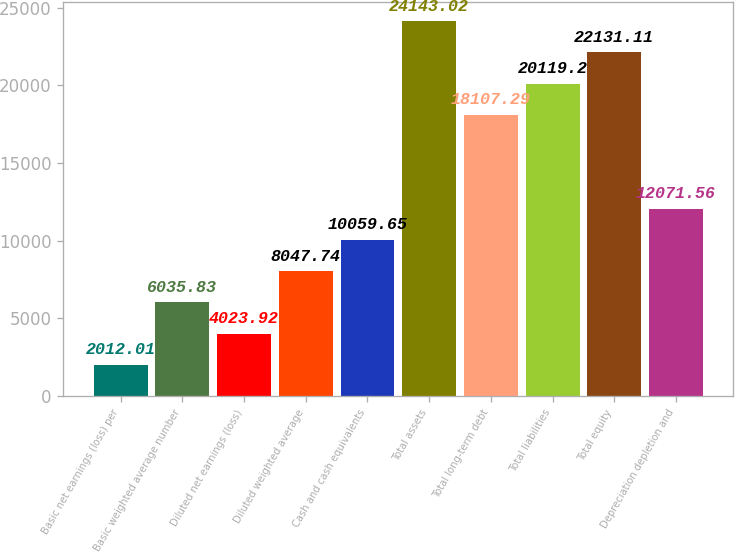<chart> <loc_0><loc_0><loc_500><loc_500><bar_chart><fcel>Basic net earnings (loss) per<fcel>Basic weighted average number<fcel>Diluted net earnings (loss)<fcel>Diluted weighted average<fcel>Cash and cash equivalents<fcel>Total assets<fcel>Total long-term debt<fcel>Total liabilities<fcel>Total equity<fcel>Depreciation depletion and<nl><fcel>2012.01<fcel>6035.83<fcel>4023.92<fcel>8047.74<fcel>10059.6<fcel>24143<fcel>18107.3<fcel>20119.2<fcel>22131.1<fcel>12071.6<nl></chart> 